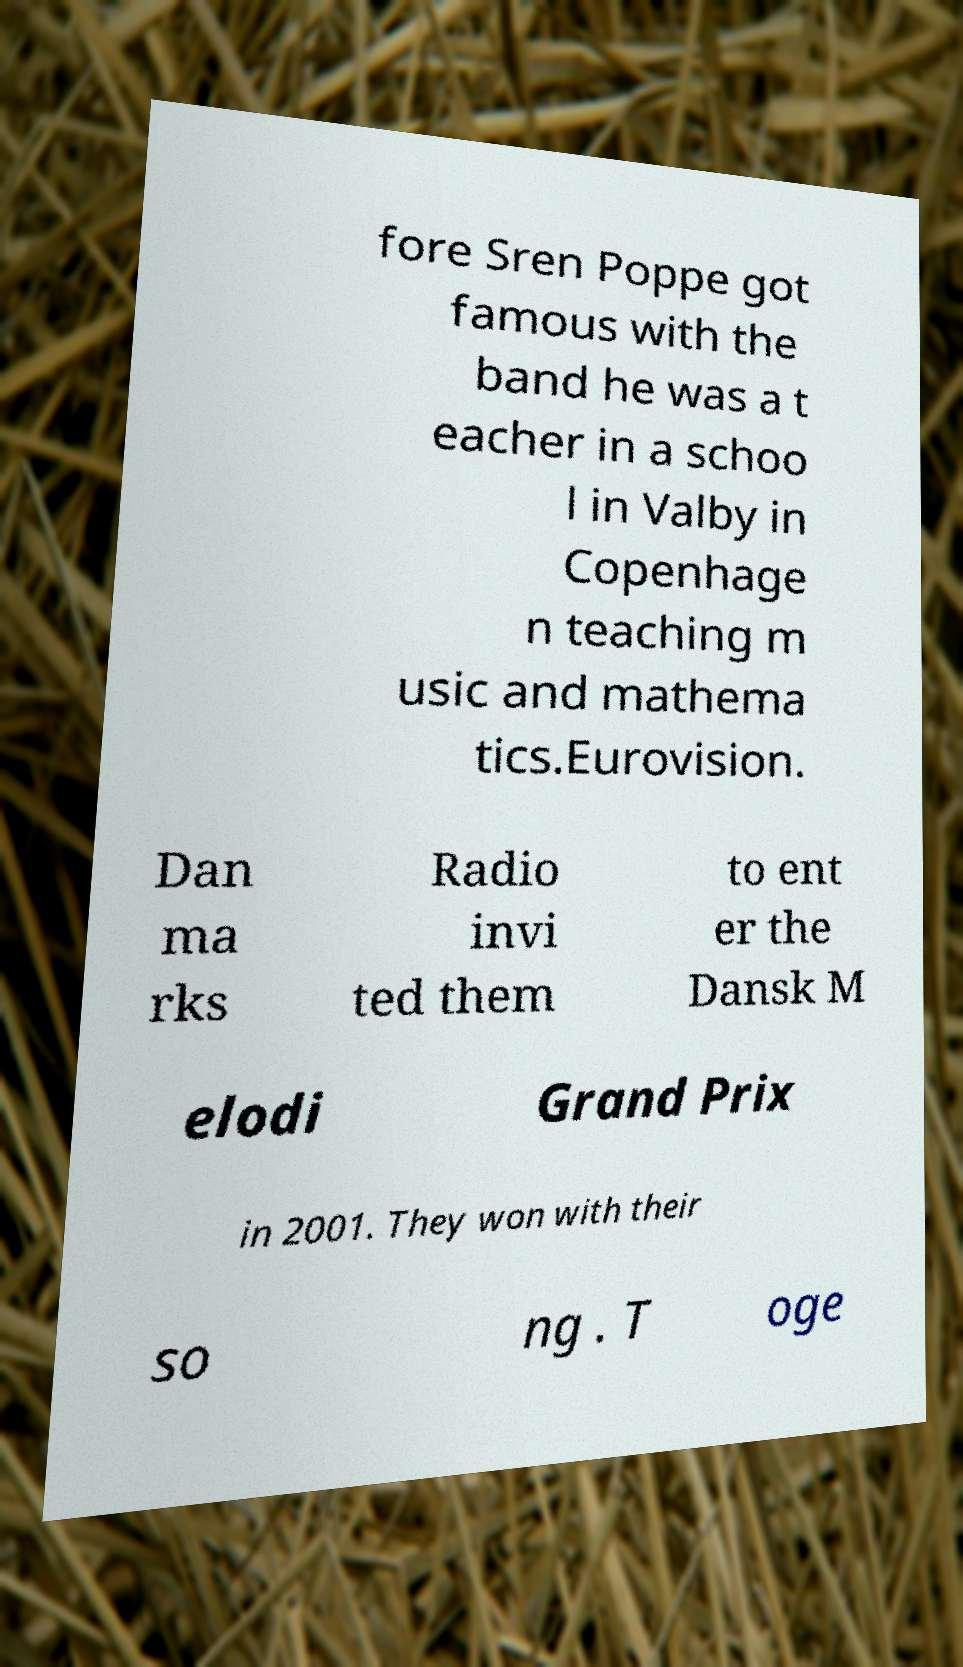For documentation purposes, I need the text within this image transcribed. Could you provide that? fore Sren Poppe got famous with the band he was a t eacher in a schoo l in Valby in Copenhage n teaching m usic and mathema tics.Eurovision. Dan ma rks Radio invi ted them to ent er the Dansk M elodi Grand Prix in 2001. They won with their so ng . T oge 